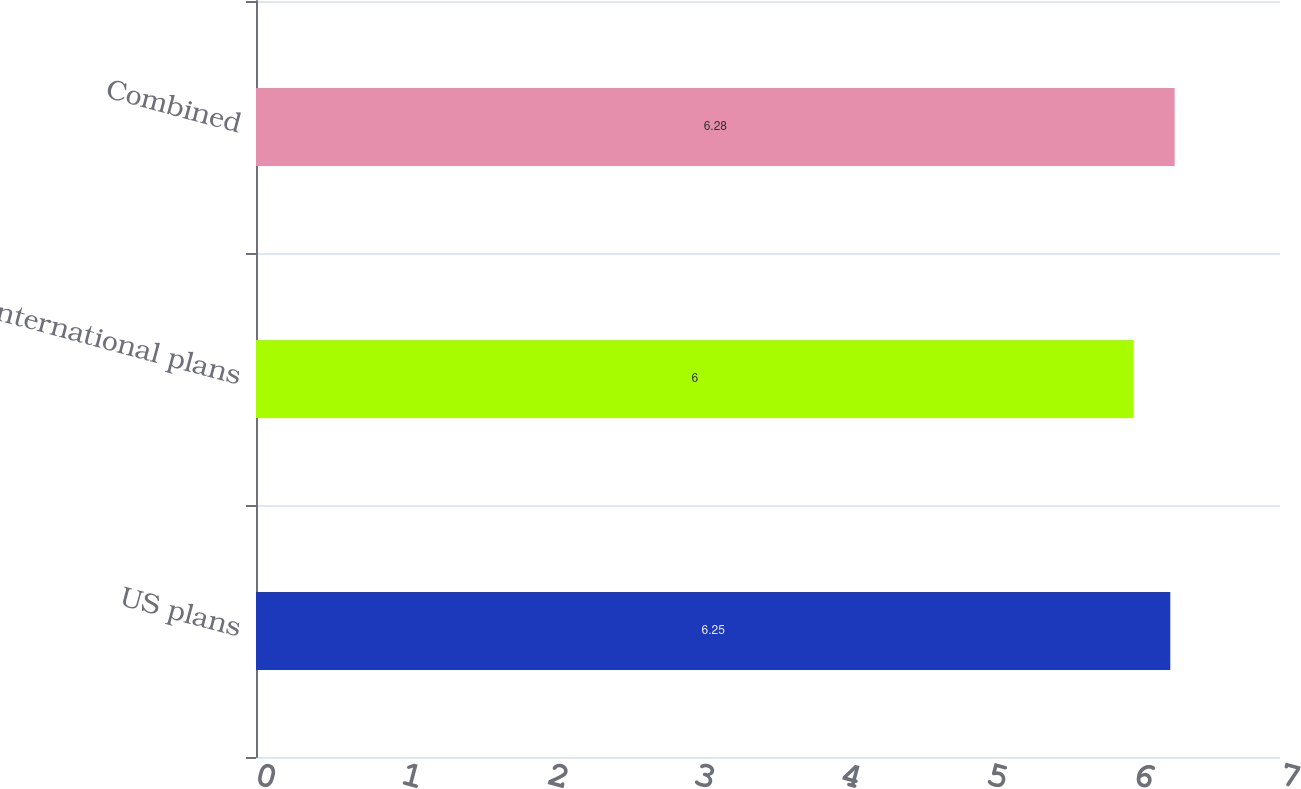<chart> <loc_0><loc_0><loc_500><loc_500><bar_chart><fcel>US plans<fcel>International plans<fcel>Combined<nl><fcel>6.25<fcel>6<fcel>6.28<nl></chart> 